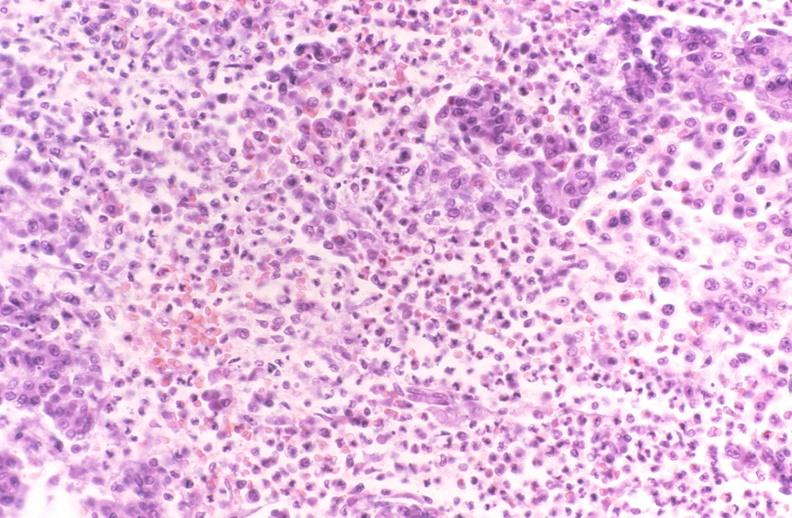what does this image show?
Answer the question using a single word or phrase. Pancreatic fat necrosis 